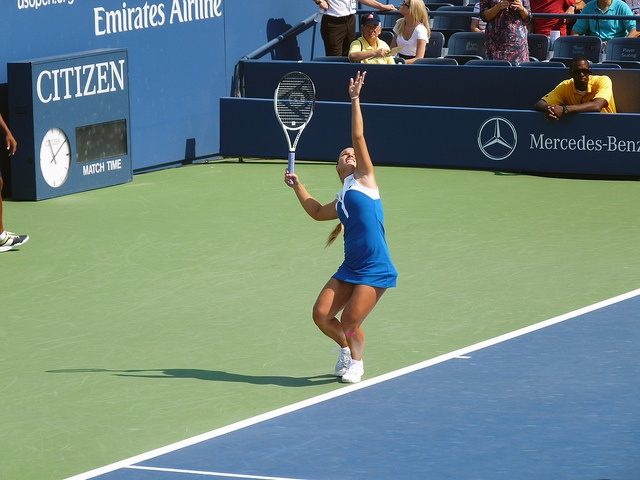Describe the objects in this image and their specific colors. I can see people in gray, navy, maroon, and blue tones, people in gray, black, maroon, olive, and khaki tones, tennis racket in gray, black, darkgray, and navy tones, people in gray, black, and maroon tones, and people in gray, black, white, and maroon tones in this image. 